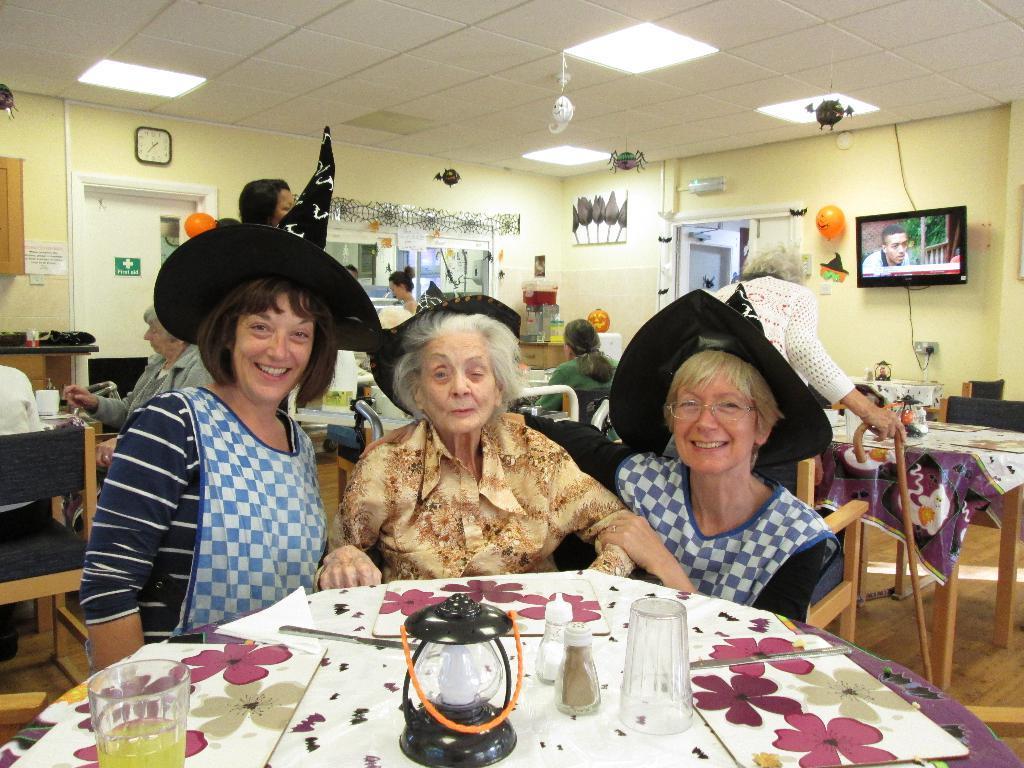Can you describe this image briefly? The picture is taken Inside the restaurant there are multiple tables and some people are sitting around a table , to the wall in the right side there is a television and some balloons to the wall ,in the background there is a clock, the first aid room and a cream color wall. 